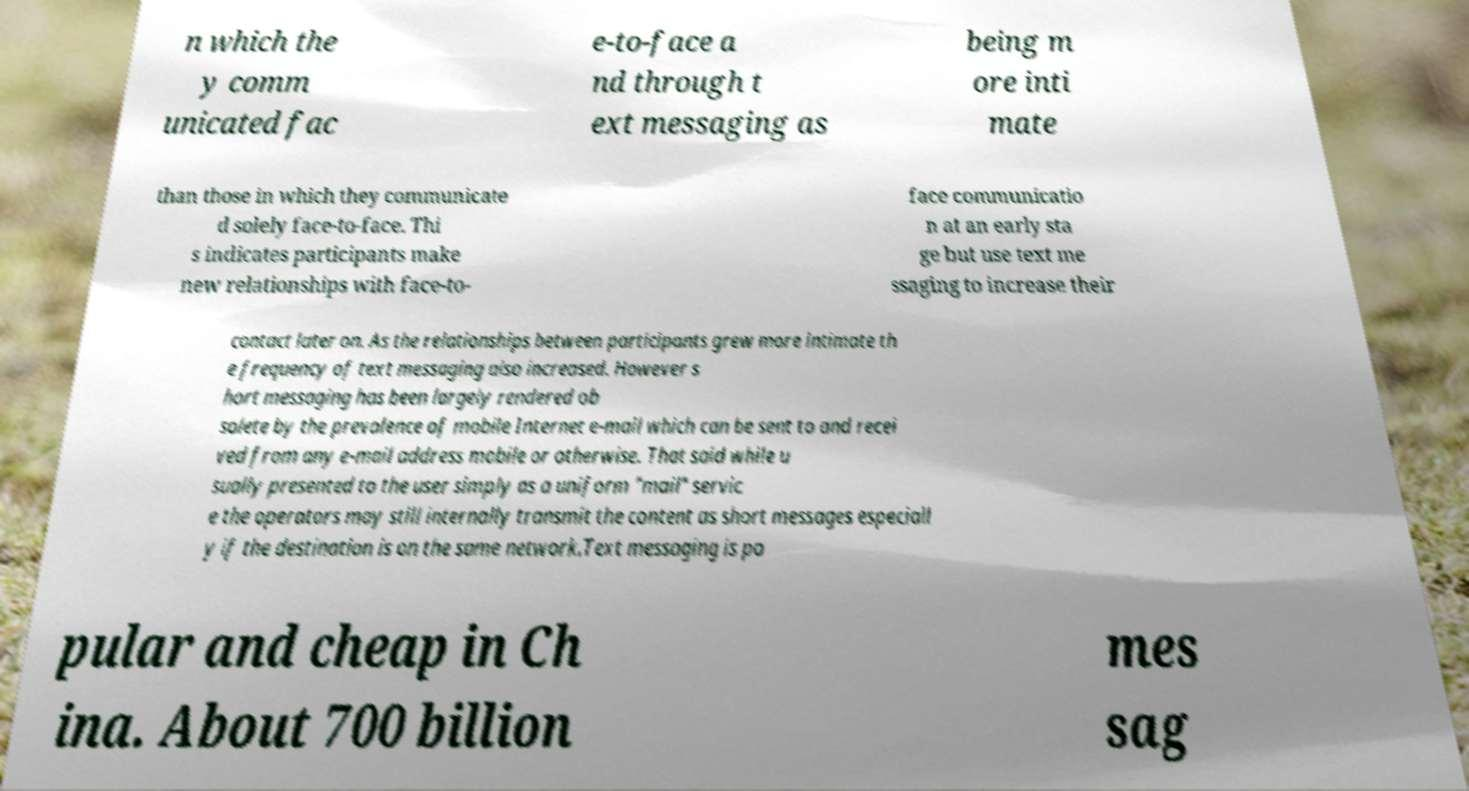Can you accurately transcribe the text from the provided image for me? n which the y comm unicated fac e-to-face a nd through t ext messaging as being m ore inti mate than those in which they communicate d solely face-to-face. Thi s indicates participants make new relationships with face-to- face communicatio n at an early sta ge but use text me ssaging to increase their contact later on. As the relationships between participants grew more intimate th e frequency of text messaging also increased. However s hort messaging has been largely rendered ob solete by the prevalence of mobile Internet e-mail which can be sent to and recei ved from any e-mail address mobile or otherwise. That said while u sually presented to the user simply as a uniform "mail" servic e the operators may still internally transmit the content as short messages especiall y if the destination is on the same network.Text messaging is po pular and cheap in Ch ina. About 700 billion mes sag 